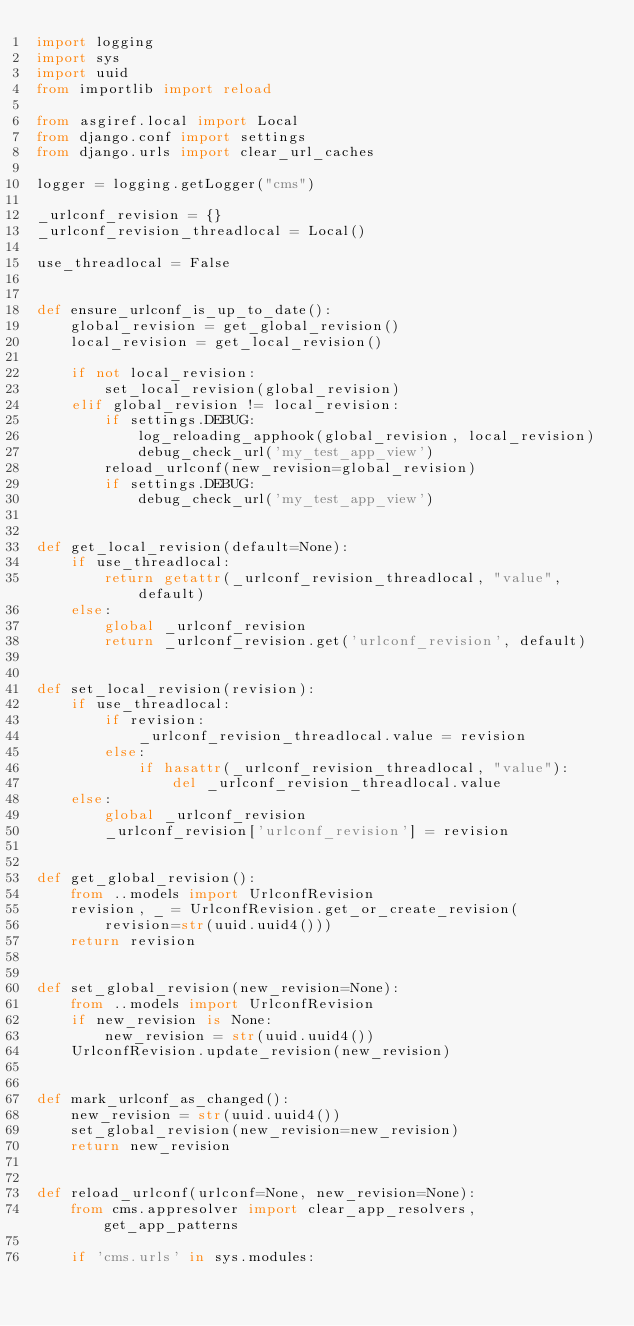Convert code to text. <code><loc_0><loc_0><loc_500><loc_500><_Python_>import logging
import sys
import uuid
from importlib import reload

from asgiref.local import Local
from django.conf import settings
from django.urls import clear_url_caches

logger = logging.getLogger("cms")

_urlconf_revision = {}
_urlconf_revision_threadlocal = Local()

use_threadlocal = False


def ensure_urlconf_is_up_to_date():
    global_revision = get_global_revision()
    local_revision = get_local_revision()

    if not local_revision:
        set_local_revision(global_revision)
    elif global_revision != local_revision:
        if settings.DEBUG:
            log_reloading_apphook(global_revision, local_revision)
            debug_check_url('my_test_app_view')
        reload_urlconf(new_revision=global_revision)
        if settings.DEBUG:
            debug_check_url('my_test_app_view')


def get_local_revision(default=None):
    if use_threadlocal:
        return getattr(_urlconf_revision_threadlocal, "value", default)
    else:
        global _urlconf_revision
        return _urlconf_revision.get('urlconf_revision', default)


def set_local_revision(revision):
    if use_threadlocal:
        if revision:
            _urlconf_revision_threadlocal.value = revision
        else:
            if hasattr(_urlconf_revision_threadlocal, "value"):
                del _urlconf_revision_threadlocal.value
    else:
        global _urlconf_revision
        _urlconf_revision['urlconf_revision'] = revision


def get_global_revision():
    from ..models import UrlconfRevision
    revision, _ = UrlconfRevision.get_or_create_revision(
        revision=str(uuid.uuid4()))
    return revision


def set_global_revision(new_revision=None):
    from ..models import UrlconfRevision
    if new_revision is None:
        new_revision = str(uuid.uuid4())
    UrlconfRevision.update_revision(new_revision)


def mark_urlconf_as_changed():
    new_revision = str(uuid.uuid4())
    set_global_revision(new_revision=new_revision)
    return new_revision


def reload_urlconf(urlconf=None, new_revision=None):
    from cms.appresolver import clear_app_resolvers, get_app_patterns

    if 'cms.urls' in sys.modules:</code> 